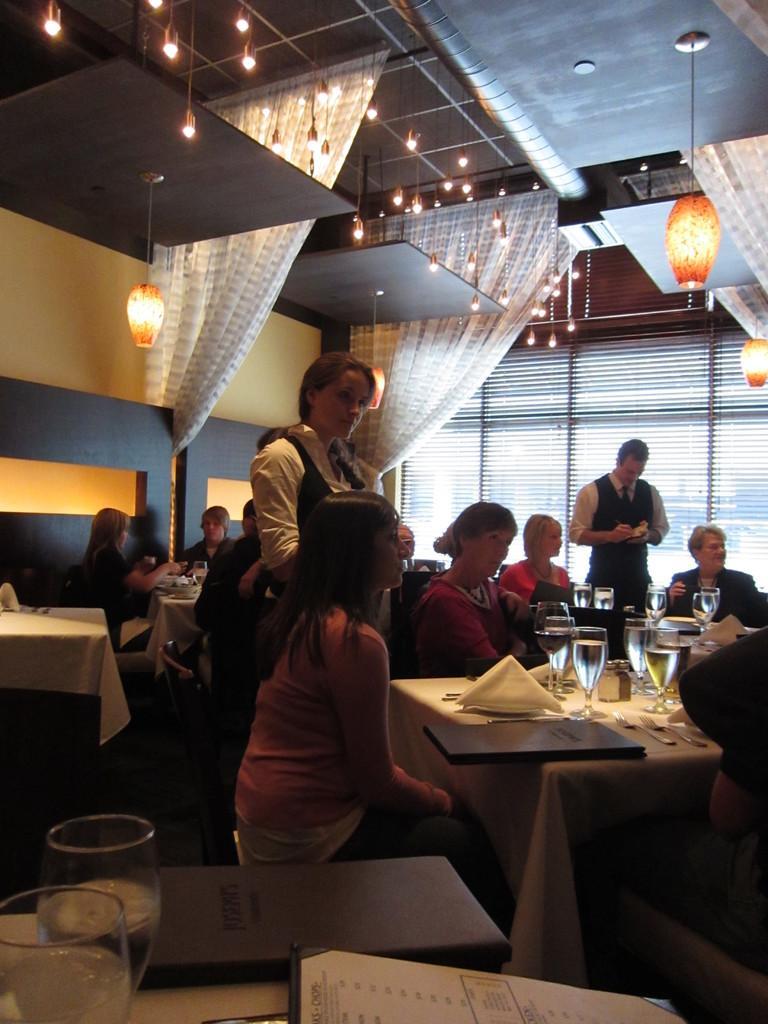Can you describe this image briefly? In this image there are group of people some of them are sitting and some of them are standing. And there are some tables, on the table there are glasses and that glasses are filled with drinks. On the table there is one book, and on the top of the image there is one ceiling that is filled with lights and some curtains, and on the right side of the image there is one window. On the left side of the image there is one wall. On the right side of the image there is a table that is covered with white cloth 